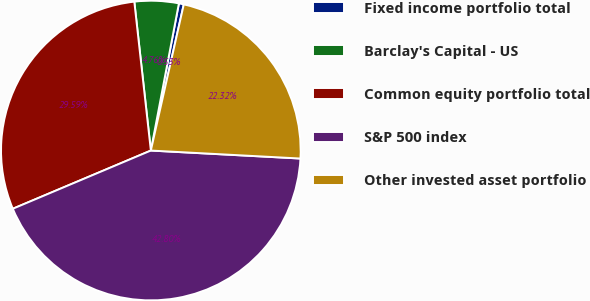<chart> <loc_0><loc_0><loc_500><loc_500><pie_chart><fcel>Fixed income portfolio total<fcel>Barclay's Capital - US<fcel>Common equity portfolio total<fcel>S&P 500 index<fcel>Other invested asset portfolio<nl><fcel>0.53%<fcel>4.76%<fcel>29.59%<fcel>42.8%<fcel>22.32%<nl></chart> 